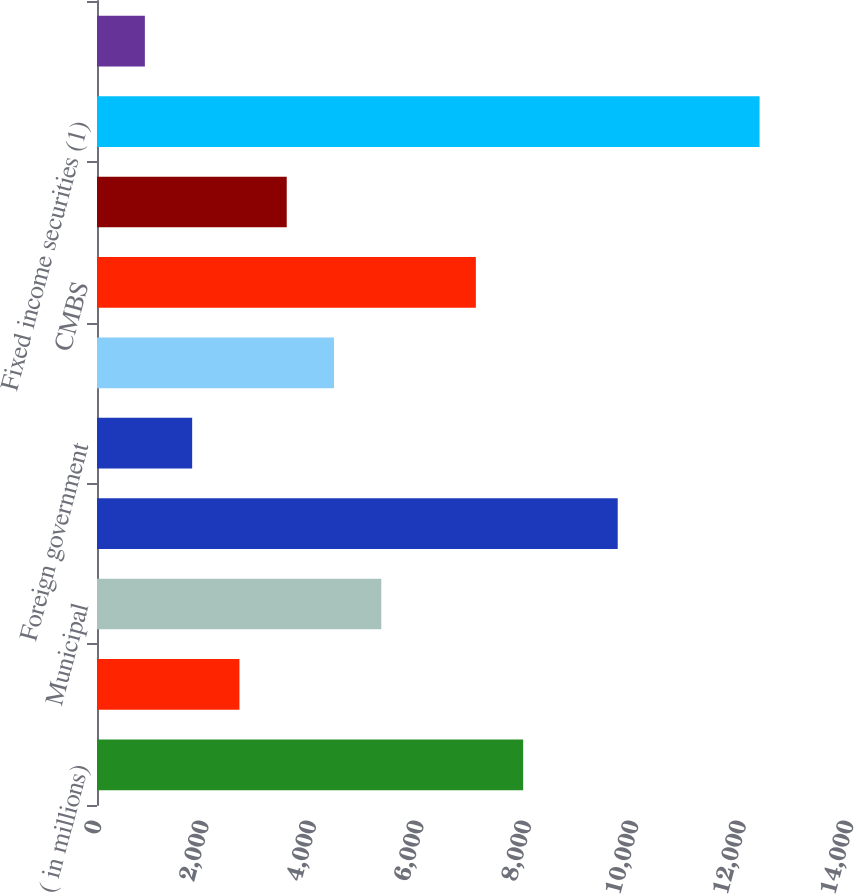<chart> <loc_0><loc_0><loc_500><loc_500><bar_chart><fcel>( in millions)<fcel>US government and agencies<fcel>Municipal<fcel>Corporate<fcel>Foreign government<fcel>RMBS<fcel>CMBS<fcel>ABS<fcel>Fixed income securities (1)<fcel>Equity securities<nl><fcel>7933.7<fcel>2651.9<fcel>5292.8<fcel>9694.3<fcel>1771.6<fcel>4412.5<fcel>7053.4<fcel>3532.2<fcel>12335.2<fcel>891.3<nl></chart> 